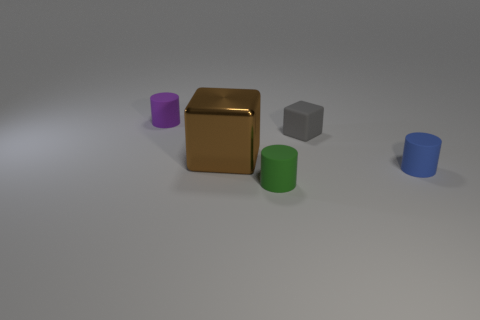What number of large brown objects are on the right side of the cylinder on the right side of the rubber thing in front of the tiny blue object?
Offer a very short reply. 0. The object that is both on the left side of the tiny green cylinder and in front of the small purple matte thing is made of what material?
Offer a very short reply. Metal. Does the blue object have the same material as the cube that is in front of the small rubber block?
Give a very brief answer. No. Are there more small matte objects that are behind the blue matte cylinder than small gray matte blocks in front of the brown block?
Your answer should be very brief. Yes. What is the shape of the gray matte thing?
Ensure brevity in your answer.  Cube. Are the tiny object on the left side of the big brown cube and the brown thing that is on the left side of the tiny green matte cylinder made of the same material?
Keep it short and to the point. No. The large brown metallic object that is to the left of the green matte cylinder has what shape?
Offer a terse response. Cube. The green object that is the same shape as the purple thing is what size?
Ensure brevity in your answer.  Small. There is a small rubber cylinder that is behind the big block; are there any cylinders that are right of it?
Keep it short and to the point. Yes. There is another thing that is the same shape as the gray matte object; what color is it?
Keep it short and to the point. Brown. 